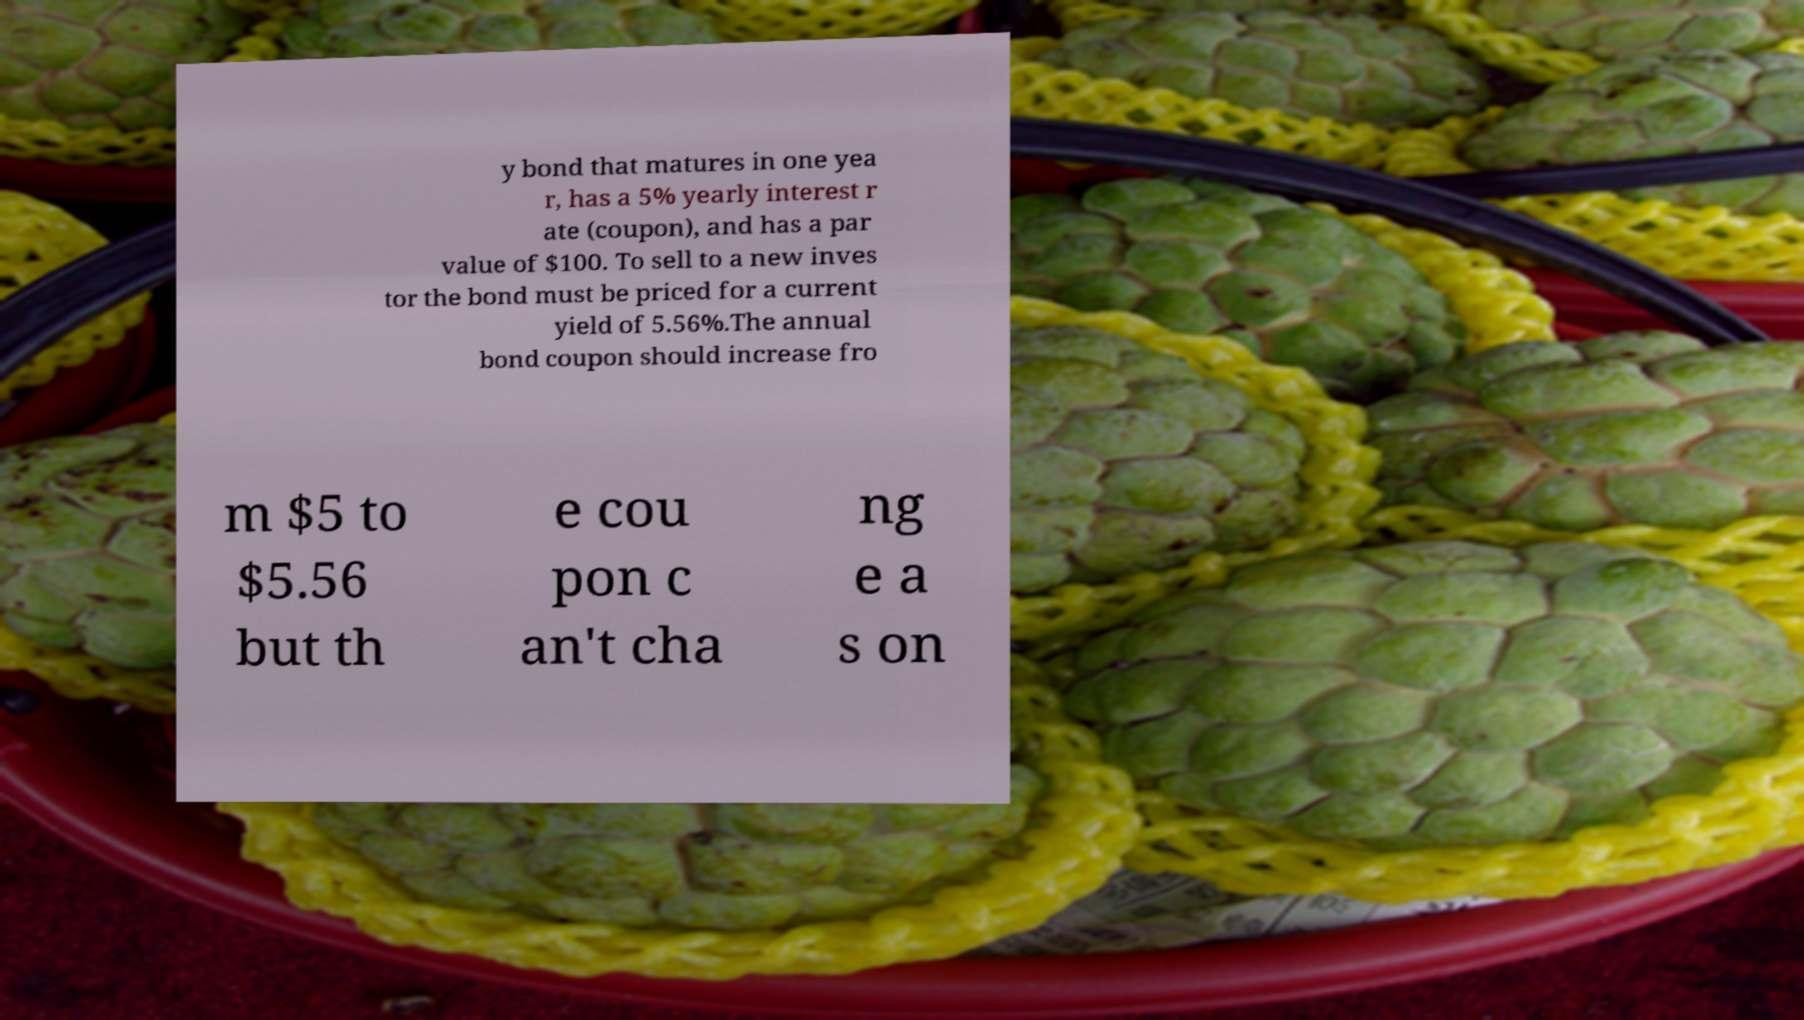Can you read and provide the text displayed in the image?This photo seems to have some interesting text. Can you extract and type it out for me? y bond that matures in one yea r, has a 5% yearly interest r ate (coupon), and has a par value of $100. To sell to a new inves tor the bond must be priced for a current yield of 5.56%.The annual bond coupon should increase fro m $5 to $5.56 but th e cou pon c an't cha ng e a s on 